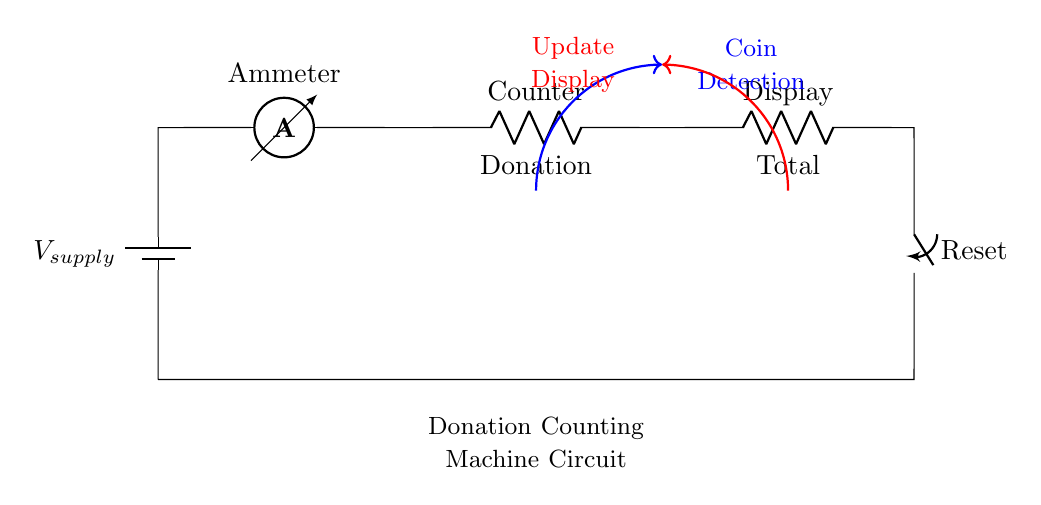What is the supply voltage in this circuit? The circuit shows a component labeled as V_supply, which indicates the source voltage for the circuit. However, a specific value is not provided in the diagram.
Answer: V_supply What components are present in this donation counting machine circuit? The circuit includes a battery, an ammeter, a counter, a display, and a reset switch. These elements work together to measure and display the donation amount.
Answer: Battery, ammeter, counter, display, reset switch How many resistors are used in the circuit? The circuit has two resistors labeled as Counter and Display. These are responsible for handling the electrical current while ensuring proper functioning of the counting and display tasks.
Answer: 2 What action does the reset switch perform? The reset switch connects back to the battery, effectively allowing the user to reset the counter and start counting donations anew. This enables the counter to clear previous values.
Answer: Resetting the counter What does the ammeter measure in this circuit? The ammeter is positioned to measure the current flowing through the circuit, which provides insight into how much charge is used for measuring donations. This is crucial for the operation of the counting machine.
Answer: Current Why does the circuit use a series configuration? The components are connected end-to-end in a series, meaning that the same current flows through each component. This is essential for the accurate functioning of devices like the donation counter, ensuring all parts are powered equally.
Answer: It ensures uniform current flow 